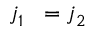Convert formula to latex. <formula><loc_0><loc_0><loc_500><loc_500>j _ { 1 } ^ { \, } = j _ { 2 } ^ { \, }</formula> 